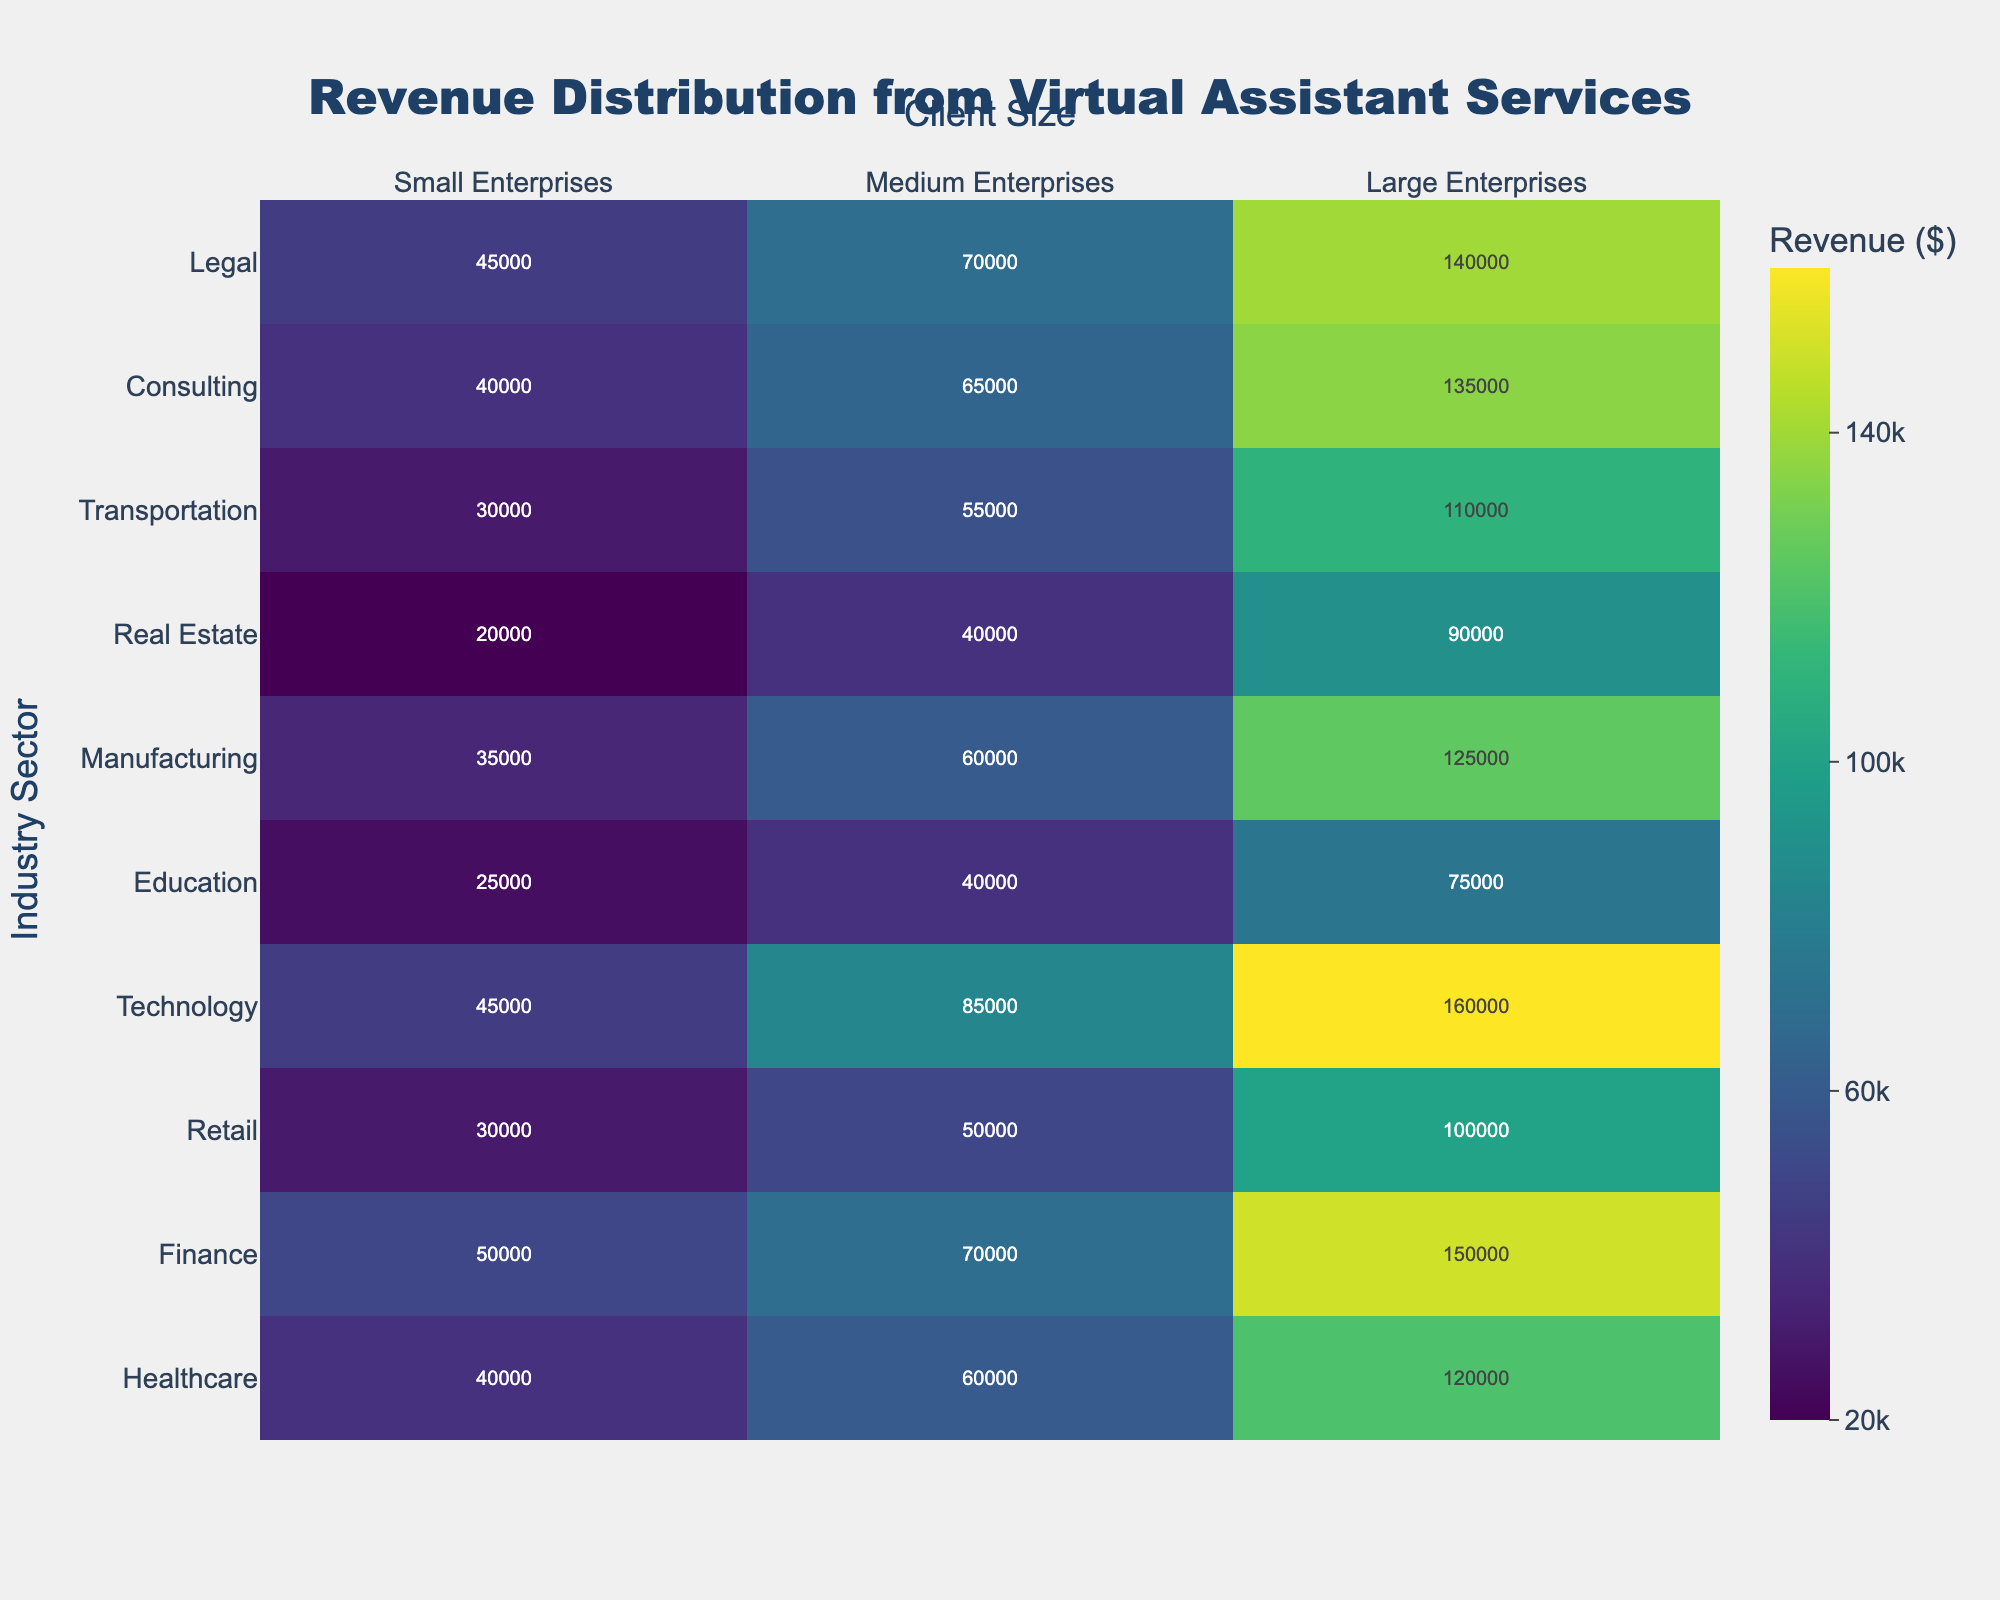What's the title of the heatmap? The title is clearly shown at the top of the heatmap. It reads "Revenue Distribution from Virtual Assistant Services".
Answer: Revenue Distribution from Virtual Assistant Services How many enterprise sizes are represented in the heatmap? There are three categories mentioned along the x-axis, which are "Small Enterprises", "Medium Enterprises", and "Large Enterprises".
Answer: Three Which industry sector has the highest revenue from Large Enterprises? Look at the column for Large Enterprises and identify the highest value, which is 160,000 in the Technology row.
Answer: Technology What is the range of revenue values represented in the heatmap? The colorbar on the right side of the heatmap shows tick values from the lowest, 20k, to the highest, 140k.
Answer: 20,000 to 160,000 Which industry sector has the lowest revenue from Small Enterprises? Look at the first column for Small Enterprises and identify the smallest value, which is 20,000 in the Real Estate row.
Answer: Real Estate What is the average revenue for the Finance sector across all enterprise sizes? Sum the revenue values for the Finance sector: 50,000 (Small) + 70,000 (Medium) + 150,000 (Large) = 270,000. Then divide by the number of categories (3) to get the average.
Answer: 90,000 How does the revenue from Medium Enterprises in the Healthcare sector compare to the revenue from Medium Enterprises in the Retail sector? Look at the values for Medium Enterprises in both sectors: Healthcare is 60,000, and Retail is 50,000. 60,000 is greater than 50,000.
Answer: Healthcare has higher revenue What is the median revenue value for Technology across all client sizes? Arrange the Technology sector values in ascending order: 45,000 (Small), 85,000 (Medium), and 160,000 (Large). The median value is the middle one, which is 85,000.
Answer: 85,000 Which enterprise size generates the highest total revenue in the Manufacturing sector? Sum the revenue values for each enterprise size in the Manufacturing sector: Small (35,000), Medium (60,000), Large (125,000). The highest value is for Large Enterprises.
Answer: Large Enterprises Among all the industry sectors, which has the least revenue from Medium Enterprises? Look at the column for Medium Enterprises and identify the smallest value, which is 40,000 in the Education and Real Estate rows.
Answer: Education and Real Estate 